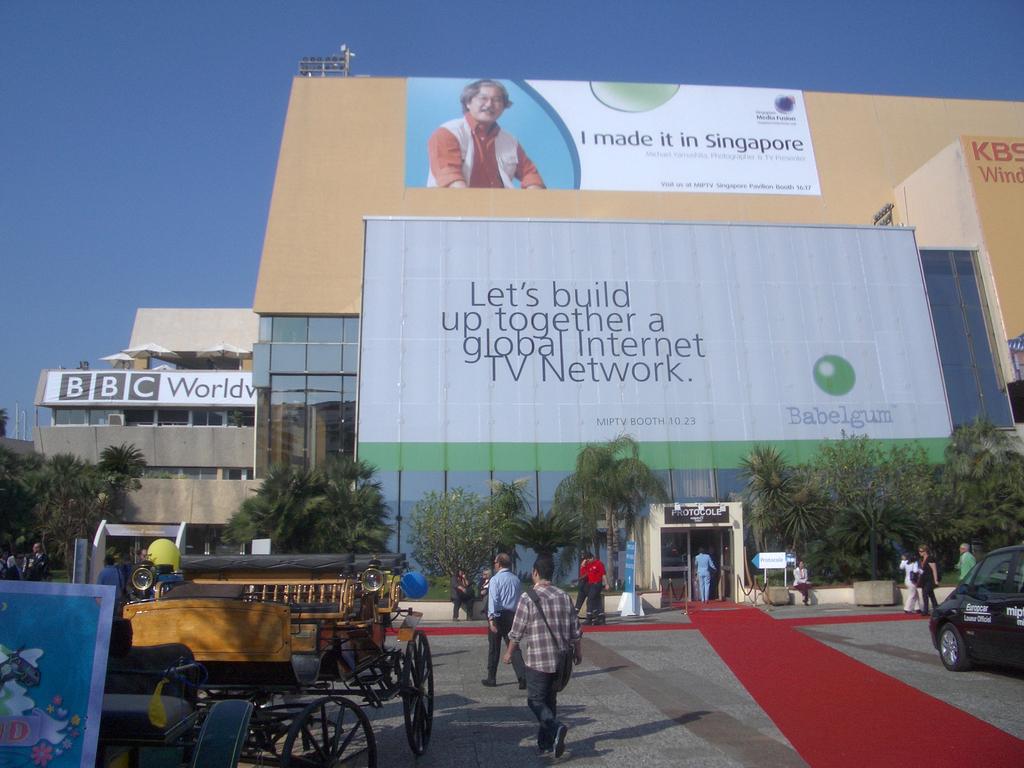What should they build together?
Your answer should be compact. Global internet tv network. What country did they make it in?
Provide a succinct answer. Singapore. 